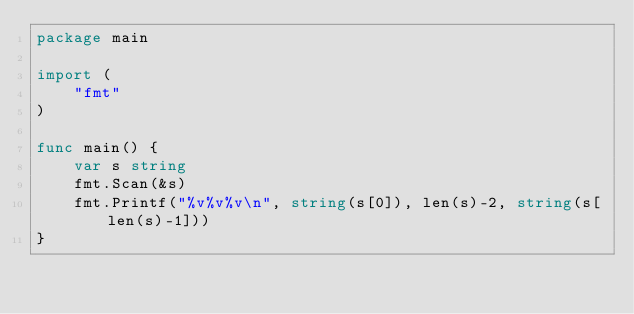<code> <loc_0><loc_0><loc_500><loc_500><_Go_>package main

import (
	"fmt"
)

func main() {
	var s string
	fmt.Scan(&s)
	fmt.Printf("%v%v%v\n", string(s[0]), len(s)-2, string(s[len(s)-1]))
}
</code> 